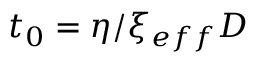<formula> <loc_0><loc_0><loc_500><loc_500>t _ { 0 } = \eta / \xi _ { e f f } D</formula> 